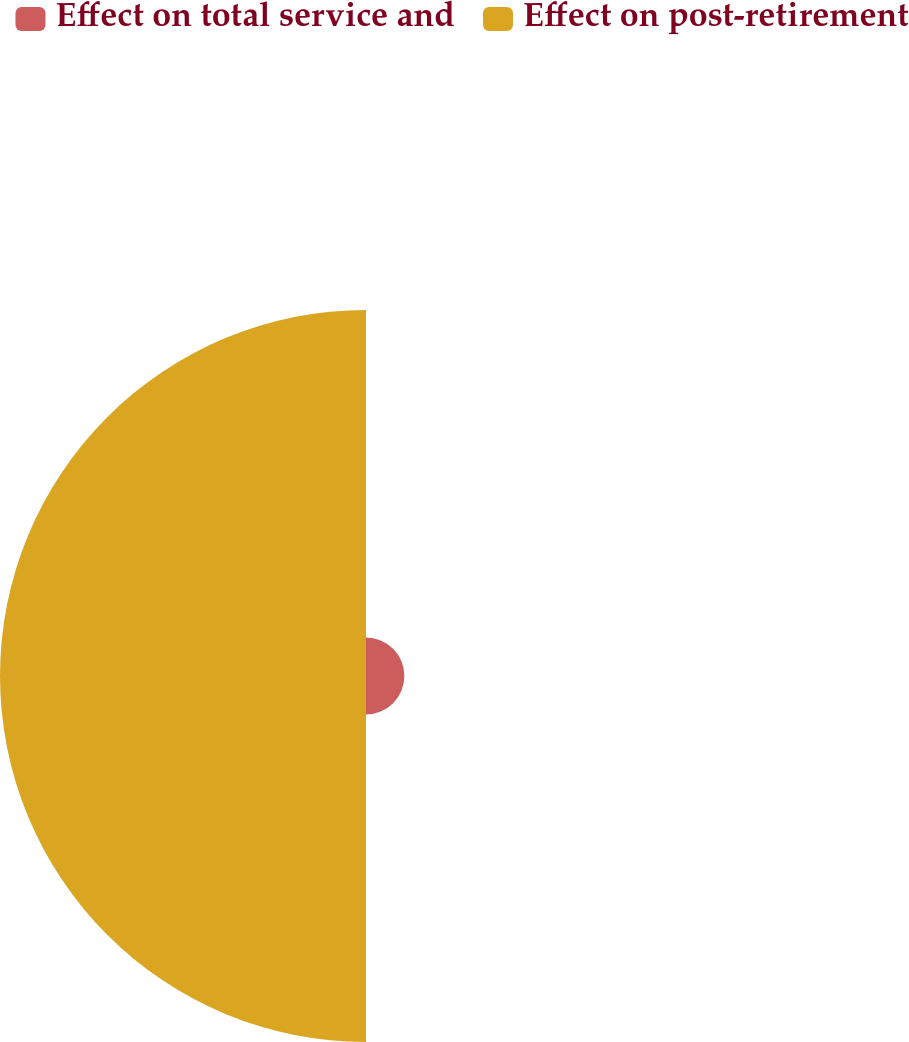<chart> <loc_0><loc_0><loc_500><loc_500><pie_chart><fcel>Effect on total service and<fcel>Effect on post-retirement<nl><fcel>9.49%<fcel>90.51%<nl></chart> 